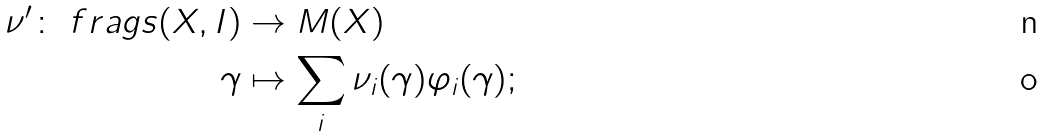Convert formula to latex. <formula><loc_0><loc_0><loc_500><loc_500>\nu ^ { \prime } \colon \ f r a g s ( X , I ) & \to M ( X ) \\ \gamma & \mapsto \sum _ { i } \nu _ { i } ( \gamma ) \varphi _ { i } ( \gamma ) ;</formula> 